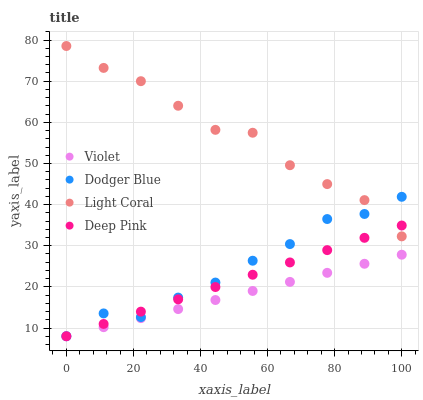Does Violet have the minimum area under the curve?
Answer yes or no. Yes. Does Light Coral have the maximum area under the curve?
Answer yes or no. Yes. Does Deep Pink have the minimum area under the curve?
Answer yes or no. No. Does Deep Pink have the maximum area under the curve?
Answer yes or no. No. Is Violet the smoothest?
Answer yes or no. Yes. Is Light Coral the roughest?
Answer yes or no. Yes. Is Deep Pink the smoothest?
Answer yes or no. No. Is Deep Pink the roughest?
Answer yes or no. No. Does Deep Pink have the lowest value?
Answer yes or no. Yes. Does Light Coral have the highest value?
Answer yes or no. Yes. Does Deep Pink have the highest value?
Answer yes or no. No. Is Violet less than Light Coral?
Answer yes or no. Yes. Is Light Coral greater than Violet?
Answer yes or no. Yes. Does Dodger Blue intersect Light Coral?
Answer yes or no. Yes. Is Dodger Blue less than Light Coral?
Answer yes or no. No. Is Dodger Blue greater than Light Coral?
Answer yes or no. No. Does Violet intersect Light Coral?
Answer yes or no. No. 